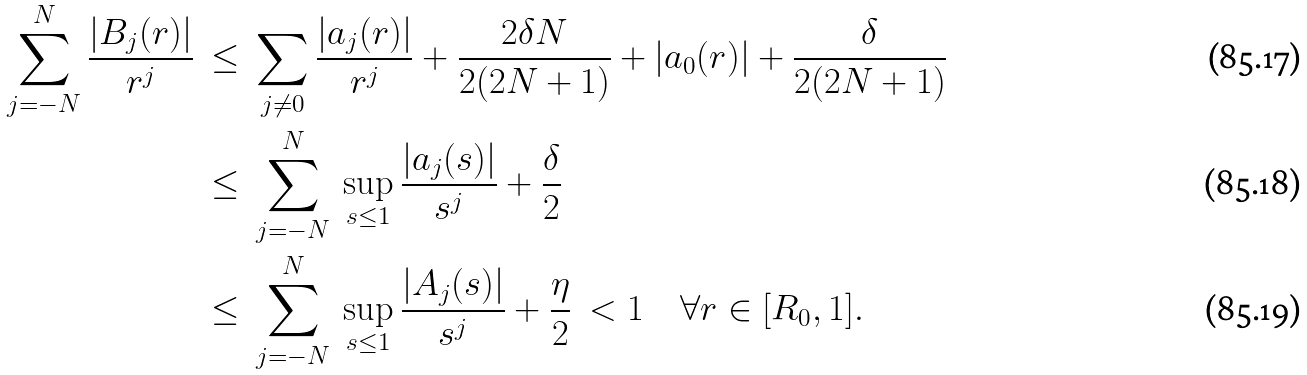<formula> <loc_0><loc_0><loc_500><loc_500>\sum _ { j = - N } ^ { N } \frac { | B _ { j } ( r ) | } { r ^ { j } } \ & \leq \ \sum _ { j \neq 0 } \frac { | a _ { j } ( r ) | } { r ^ { j } } + \frac { 2 \delta N } { 2 ( 2 N + 1 ) } + | a _ { 0 } ( r ) | + \frac { \delta } { 2 ( 2 N + 1 ) } \\ & \leq \ \sum _ { j = - N } ^ { N } \ \sup _ { s \leq 1 } \frac { | a _ { j } ( s ) | } { s ^ { j } } + \frac { \delta } { 2 } \\ & \leq \ \sum _ { j = - N } ^ { N } \ \sup _ { s \leq 1 } \frac { | A _ { j } ( s ) | } { s ^ { j } } + \frac { \eta } { 2 } \ < 1 \quad \forall r \in [ R _ { 0 } , 1 ] .</formula> 